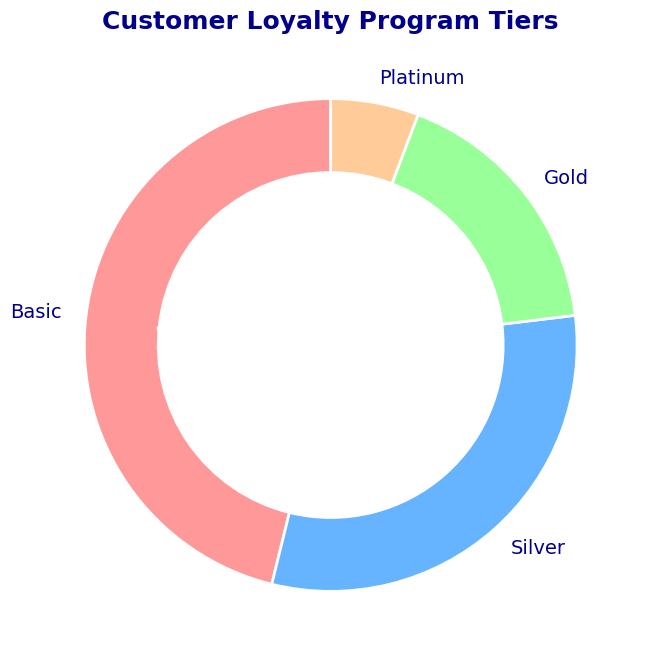What percentage of customers are in the Gold tier? The pie chart shows the percentage of customers in each tier with labels. According to the chart, the Gold tier represents 20.5% of the total customers.
Answer: 20.5% Which tier has the most customers? By looking at the slices and their respective labels on the pie chart, the Basic tier has the largest slice, indicating it has the most customers.
Answer: Basic How many more customers are in the Silver tier compared to the Platinum tier? From the pie chart, we know the number of customers: Silver has 800 and Platinum has 150. The difference is calculated as 800 - 150.
Answer: 650 What is the combined percentage of customers in the Basic and Silver tiers? The pie chart provides individual percentages: Basic (48.0%) and Silver (32.0%). Adding these percentages, the combined value is 48.0 + 32.0.
Answer: 80.0% How does the percentage of customers in the Platinum tier compare to the Gold tier? According to the pie chart, the Platinum tier has 6.0% of customers, and the Gold tier has 18.0% of customers. Thus, Platinum has one-third the percentage of the Gold tier.
Answer: One-third What is the ratio of customers in the Basic tier to the total number of customers in the Gold and Platinum tiers combined? The pie chart shows the number of customers: Basic (1200), Gold (450), and Platinum (150). The total number of Gold and Platinum customers is 450 + 150 = 600. The ratio is then 1200/600.
Answer: 2:1 What percentage of the total customers belong to either the Gold or Platinum tier? By referring to the pie chart, we see the Gold tier has 18.0% and the Platinum tier has 6.0%. Adding these, we get 18.0 + 6.0.
Answer: 24.0% Which tiers combined have the same number of customers as the Basic tier? The number of customers in the Basic tier is 1200. Adding customers from Silver (800) and Gold (450) gives 800 + 450 = 1250, which exceeds 1200. Considering Silver and Platinum, 800 + 150 = 950, which is less. Thus, no combination matches exactly.
Answer: None What is the approximate difference in percentage between the Basic and Silver tiers? According to the pie chart, the Basic tier accounts for 48.0% and the Silver tier for 32.0%. The difference between these percentages is 48.0 - 32.0.
Answer: 16.0% What is the total number of customers represented in the pie chart? By summing the numbers from each tier: Basic (1200), Silver (800), Gold (450), and Platinum (150), the total number of customers is 1200 + 800 + 450 + 150.
Answer: 2600 